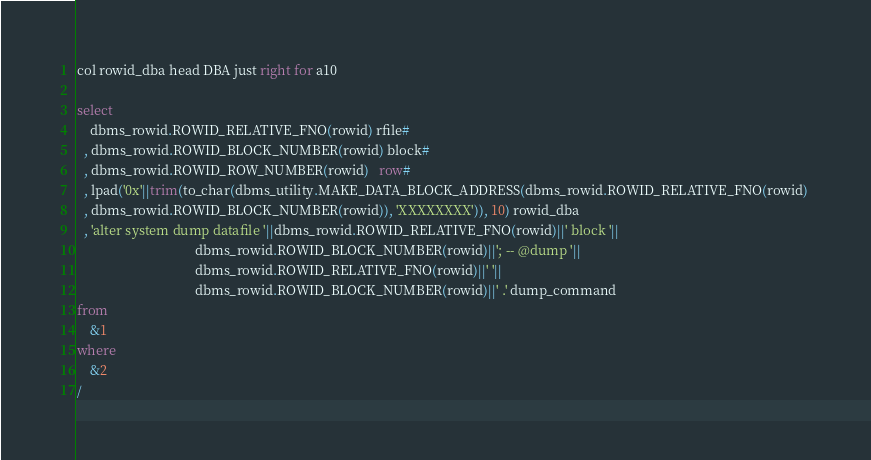<code> <loc_0><loc_0><loc_500><loc_500><_SQL_>col rowid_dba head DBA just right for a10

select
    dbms_rowid.ROWID_RELATIVE_FNO(rowid) rfile#
  , dbms_rowid.ROWID_BLOCK_NUMBER(rowid) block#
  , dbms_rowid.ROWID_ROW_NUMBER(rowid)   row#
  , lpad('0x'||trim(to_char(dbms_utility.MAKE_DATA_BLOCK_ADDRESS(dbms_rowid.ROWID_RELATIVE_FNO(rowid) 
  , dbms_rowid.ROWID_BLOCK_NUMBER(rowid)), 'XXXXXXXX')), 10) rowid_dba
  , 'alter system dump datafile '||dbms_rowid.ROWID_RELATIVE_FNO(rowid)||' block '||
                                   dbms_rowid.ROWID_BLOCK_NUMBER(rowid)||'; -- @dump '||
                                   dbms_rowid.ROWID_RELATIVE_FNO(rowid)||' '||
                                   dbms_rowid.ROWID_BLOCK_NUMBER(rowid)||' .' dump_command
from
    &1
where
    &2
/
</code> 